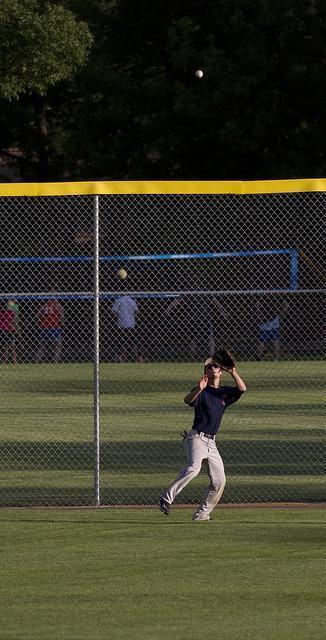What position is this player playing?
Make your selection and explain in format: 'Answer: answer
Rationale: rationale.'
Options: Pitcher, outfielder, catcher, 1st base. Answer: outfielder.
Rationale: A baseball player is in the grassy part of a baseball diamond. outfielders stand in the grassy part of the field. 